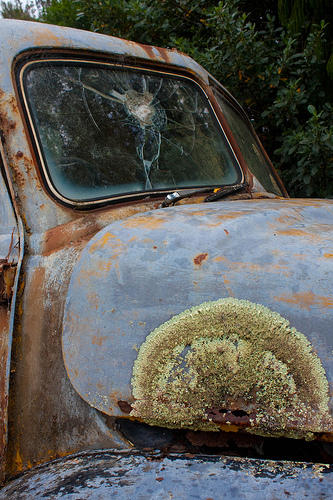<image>
Is the crack under the window? No. The crack is not positioned under the window. The vertical relationship between these objects is different. 